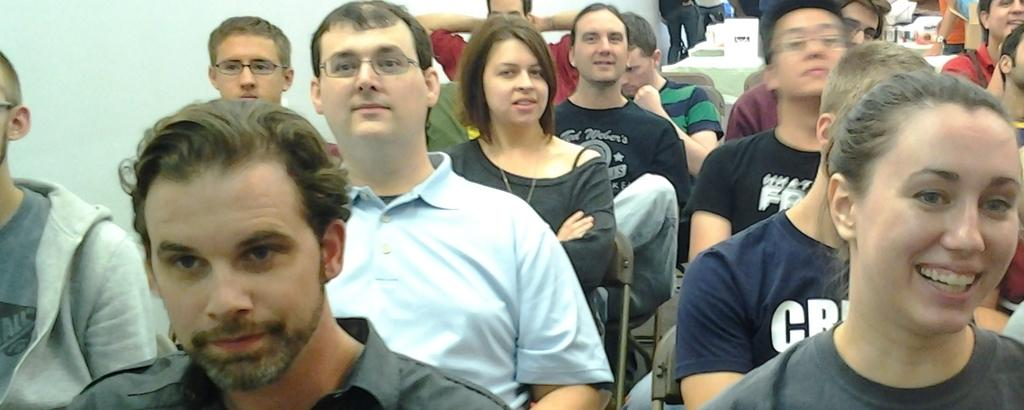What are the persons in the image wearing? The persons in the image are wearing clothes. What are the persons doing in the image? Some persons are sitting on chairs in the image. What can be seen in the top left of the image? There is a wall visible in the top left of the image. What is the price of the boat in the image? There is no boat present in the image, so it is not possible to determine its price. 